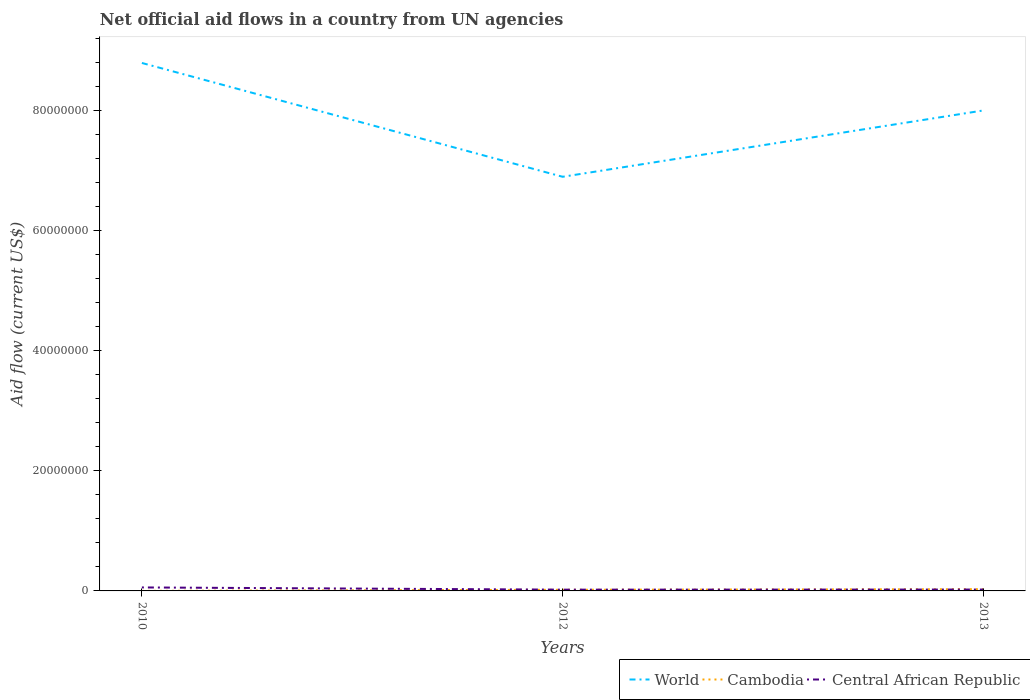How many different coloured lines are there?
Provide a succinct answer. 3. In which year was the net official aid flow in World maximum?
Your answer should be compact. 2012. What is the total net official aid flow in Cambodia in the graph?
Your answer should be very brief. -1.80e+05. What is the difference between the highest and the second highest net official aid flow in Cambodia?
Make the answer very short. 2.80e+05. How many lines are there?
Give a very brief answer. 3. How many years are there in the graph?
Provide a succinct answer. 3. Does the graph contain any zero values?
Make the answer very short. No. Does the graph contain grids?
Provide a short and direct response. No. How are the legend labels stacked?
Offer a very short reply. Horizontal. What is the title of the graph?
Provide a succinct answer. Net official aid flows in a country from UN agencies. Does "Cambodia" appear as one of the legend labels in the graph?
Provide a succinct answer. Yes. What is the label or title of the X-axis?
Make the answer very short. Years. What is the label or title of the Y-axis?
Make the answer very short. Aid flow (current US$). What is the Aid flow (current US$) in World in 2010?
Keep it short and to the point. 8.79e+07. What is the Aid flow (current US$) of Cambodia in 2010?
Ensure brevity in your answer.  10000. What is the Aid flow (current US$) in Central African Republic in 2010?
Your answer should be very brief. 5.80e+05. What is the Aid flow (current US$) of World in 2012?
Ensure brevity in your answer.  6.89e+07. What is the Aid flow (current US$) in Central African Republic in 2012?
Your response must be concise. 2.10e+05. What is the Aid flow (current US$) in World in 2013?
Your response must be concise. 8.00e+07. What is the Aid flow (current US$) in Cambodia in 2013?
Your answer should be very brief. 2.90e+05. What is the Aid flow (current US$) in Central African Republic in 2013?
Offer a terse response. 2.30e+05. Across all years, what is the maximum Aid flow (current US$) in World?
Ensure brevity in your answer.  8.79e+07. Across all years, what is the maximum Aid flow (current US$) in Cambodia?
Keep it short and to the point. 2.90e+05. Across all years, what is the maximum Aid flow (current US$) of Central African Republic?
Your answer should be very brief. 5.80e+05. Across all years, what is the minimum Aid flow (current US$) in World?
Your answer should be very brief. 6.89e+07. Across all years, what is the minimum Aid flow (current US$) in Cambodia?
Offer a terse response. 10000. What is the total Aid flow (current US$) in World in the graph?
Provide a succinct answer. 2.37e+08. What is the total Aid flow (current US$) in Central African Republic in the graph?
Your answer should be compact. 1.02e+06. What is the difference between the Aid flow (current US$) in World in 2010 and that in 2012?
Keep it short and to the point. 1.89e+07. What is the difference between the Aid flow (current US$) in Cambodia in 2010 and that in 2012?
Offer a terse response. -1.80e+05. What is the difference between the Aid flow (current US$) of World in 2010 and that in 2013?
Give a very brief answer. 7.90e+06. What is the difference between the Aid flow (current US$) in Cambodia in 2010 and that in 2013?
Provide a short and direct response. -2.80e+05. What is the difference between the Aid flow (current US$) of Central African Republic in 2010 and that in 2013?
Offer a very short reply. 3.50e+05. What is the difference between the Aid flow (current US$) of World in 2012 and that in 2013?
Your answer should be very brief. -1.10e+07. What is the difference between the Aid flow (current US$) of Cambodia in 2012 and that in 2013?
Your answer should be compact. -1.00e+05. What is the difference between the Aid flow (current US$) of World in 2010 and the Aid flow (current US$) of Cambodia in 2012?
Your answer should be compact. 8.77e+07. What is the difference between the Aid flow (current US$) in World in 2010 and the Aid flow (current US$) in Central African Republic in 2012?
Provide a succinct answer. 8.76e+07. What is the difference between the Aid flow (current US$) of World in 2010 and the Aid flow (current US$) of Cambodia in 2013?
Provide a succinct answer. 8.76e+07. What is the difference between the Aid flow (current US$) of World in 2010 and the Aid flow (current US$) of Central African Republic in 2013?
Give a very brief answer. 8.76e+07. What is the difference between the Aid flow (current US$) in World in 2012 and the Aid flow (current US$) in Cambodia in 2013?
Your answer should be very brief. 6.86e+07. What is the difference between the Aid flow (current US$) in World in 2012 and the Aid flow (current US$) in Central African Republic in 2013?
Offer a terse response. 6.87e+07. What is the difference between the Aid flow (current US$) in Cambodia in 2012 and the Aid flow (current US$) in Central African Republic in 2013?
Provide a succinct answer. -4.00e+04. What is the average Aid flow (current US$) of World per year?
Offer a very short reply. 7.89e+07. What is the average Aid flow (current US$) of Cambodia per year?
Offer a very short reply. 1.63e+05. In the year 2010, what is the difference between the Aid flow (current US$) in World and Aid flow (current US$) in Cambodia?
Give a very brief answer. 8.78e+07. In the year 2010, what is the difference between the Aid flow (current US$) of World and Aid flow (current US$) of Central African Republic?
Offer a terse response. 8.73e+07. In the year 2010, what is the difference between the Aid flow (current US$) in Cambodia and Aid flow (current US$) in Central African Republic?
Your response must be concise. -5.70e+05. In the year 2012, what is the difference between the Aid flow (current US$) in World and Aid flow (current US$) in Cambodia?
Keep it short and to the point. 6.87e+07. In the year 2012, what is the difference between the Aid flow (current US$) in World and Aid flow (current US$) in Central African Republic?
Offer a terse response. 6.87e+07. In the year 2012, what is the difference between the Aid flow (current US$) in Cambodia and Aid flow (current US$) in Central African Republic?
Offer a terse response. -2.00e+04. In the year 2013, what is the difference between the Aid flow (current US$) of World and Aid flow (current US$) of Cambodia?
Your response must be concise. 7.97e+07. In the year 2013, what is the difference between the Aid flow (current US$) in World and Aid flow (current US$) in Central African Republic?
Keep it short and to the point. 7.97e+07. What is the ratio of the Aid flow (current US$) in World in 2010 to that in 2012?
Offer a very short reply. 1.27. What is the ratio of the Aid flow (current US$) in Cambodia in 2010 to that in 2012?
Give a very brief answer. 0.05. What is the ratio of the Aid flow (current US$) in Central African Republic in 2010 to that in 2012?
Keep it short and to the point. 2.76. What is the ratio of the Aid flow (current US$) of World in 2010 to that in 2013?
Ensure brevity in your answer.  1.1. What is the ratio of the Aid flow (current US$) of Cambodia in 2010 to that in 2013?
Keep it short and to the point. 0.03. What is the ratio of the Aid flow (current US$) of Central African Republic in 2010 to that in 2013?
Offer a terse response. 2.52. What is the ratio of the Aid flow (current US$) in World in 2012 to that in 2013?
Provide a short and direct response. 0.86. What is the ratio of the Aid flow (current US$) of Cambodia in 2012 to that in 2013?
Your answer should be compact. 0.66. What is the difference between the highest and the second highest Aid flow (current US$) of World?
Offer a terse response. 7.90e+06. What is the difference between the highest and the lowest Aid flow (current US$) of World?
Ensure brevity in your answer.  1.89e+07. 